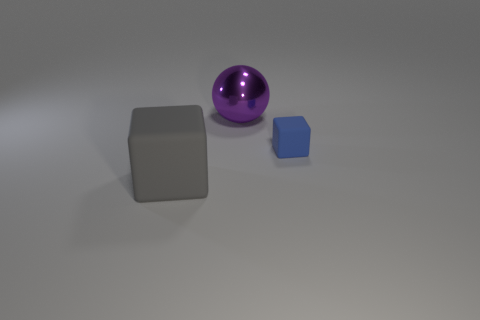How does the size of the sphere compare to the other objects? The sphere is larger than the smallest cube but smaller than the largest cube, offering a sense of graduated scale among the objects. 